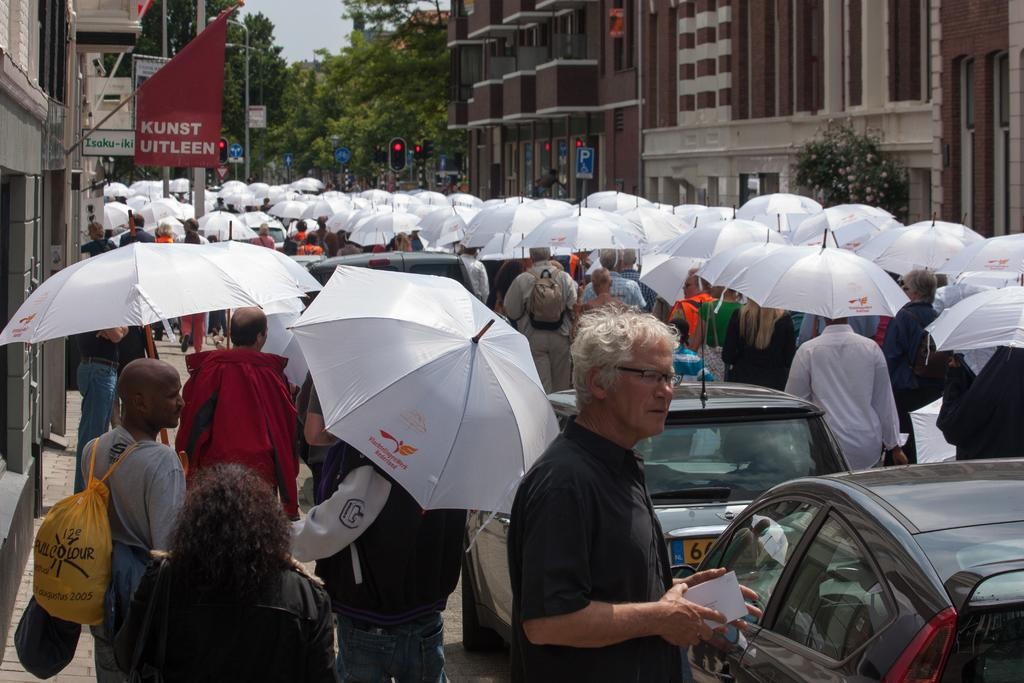What types of objects are present in the image? There are vehicles, a group of people holding umbrellas, buildings, signal lights, sign boards, trees, and the sky is visible in the image. Can you describe the people in the image? The group of people in the image are standing and holding umbrellas. What can be seen on the poles in the image? Sign boards are attached to poles in the image. What is the purpose of the signal lights in the image? The signal lights are present to regulate traffic. What type of crate is being used to store the teeth in the image? There is no crate or teeth present in the image. How many parcels are being delivered by the vehicles in the image? The image does not show any parcels being delivered by the vehicles. 